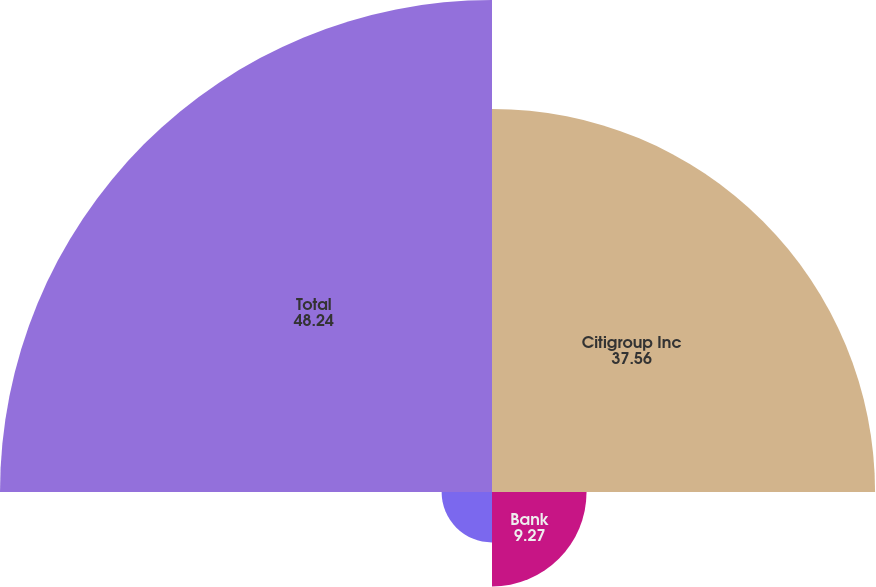Convert chart to OTSL. <chart><loc_0><loc_0><loc_500><loc_500><pie_chart><fcel>Citigroup Inc<fcel>Bank<fcel>Broker-dealer<fcel>Total<nl><fcel>37.56%<fcel>9.27%<fcel>4.94%<fcel>48.24%<nl></chart> 